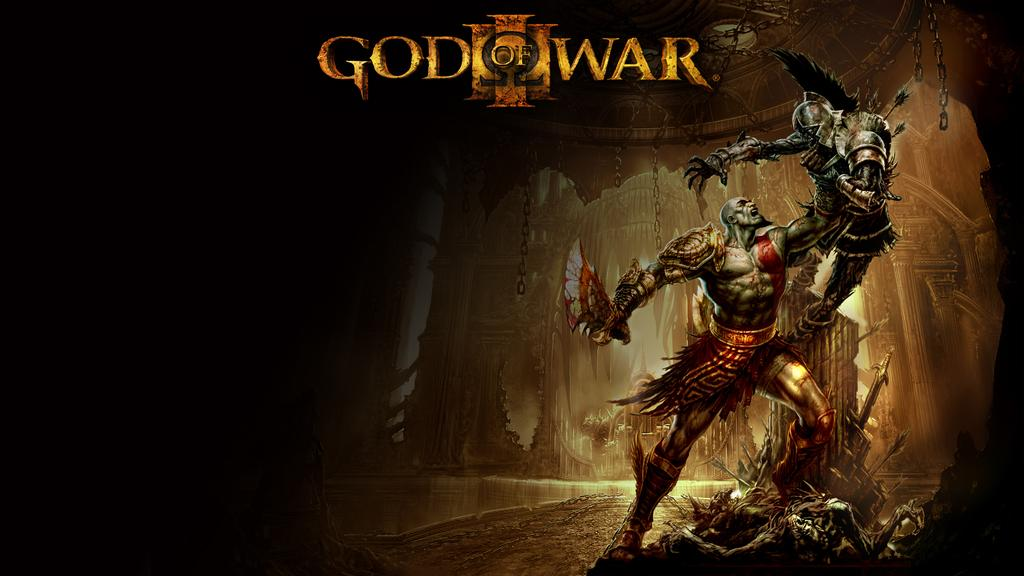<image>
Offer a succinct explanation of the picture presented. An ad for God of War features two armored men attacking each other. 